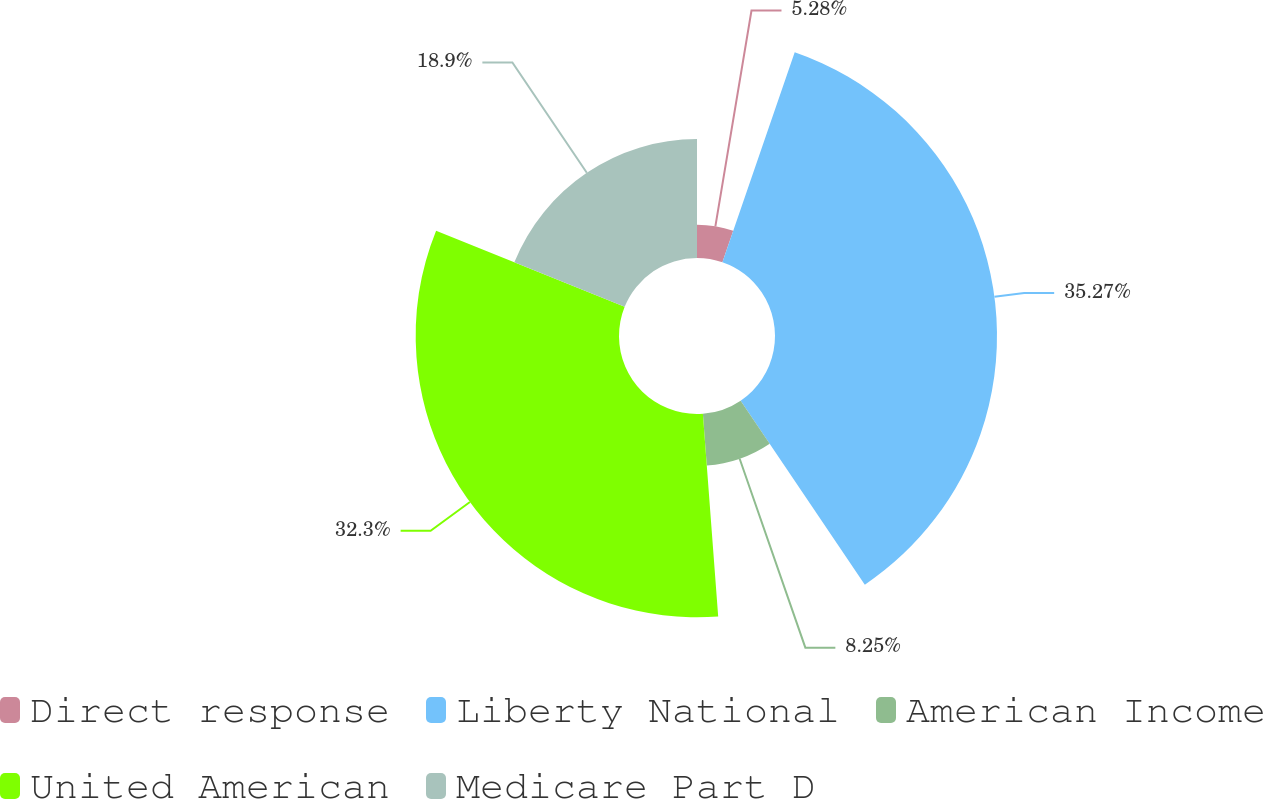<chart> <loc_0><loc_0><loc_500><loc_500><pie_chart><fcel>Direct response<fcel>Liberty National<fcel>American Income<fcel>United American<fcel>Medicare Part D<nl><fcel>5.28%<fcel>35.27%<fcel>8.25%<fcel>32.3%<fcel>18.9%<nl></chart> 